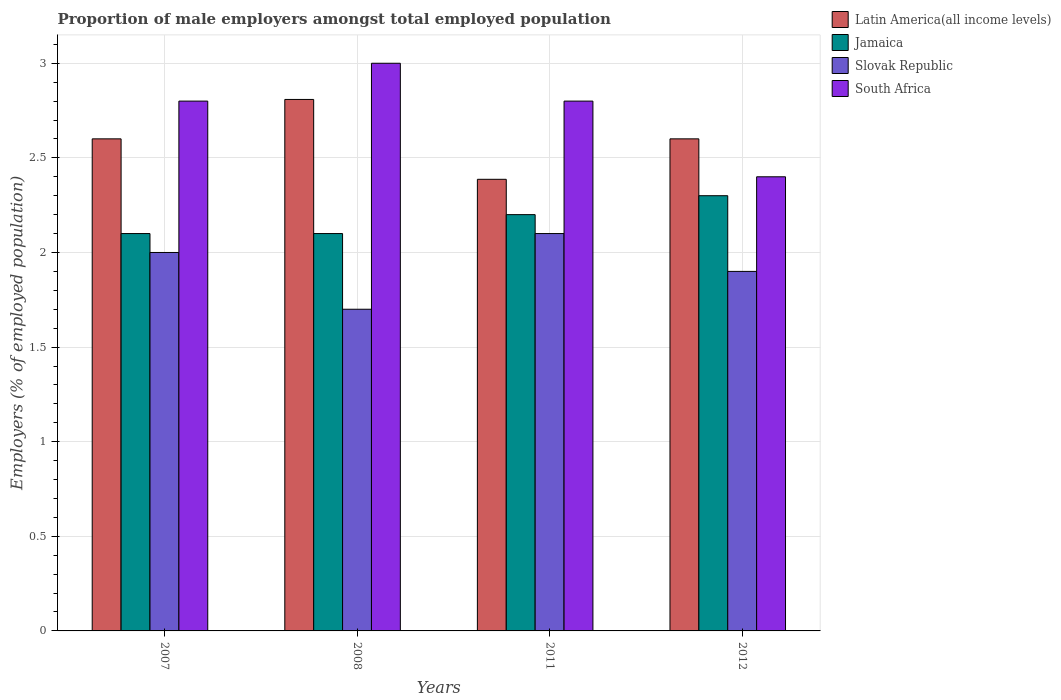How many different coloured bars are there?
Offer a very short reply. 4. How many groups of bars are there?
Your response must be concise. 4. Are the number of bars per tick equal to the number of legend labels?
Provide a succinct answer. Yes. Are the number of bars on each tick of the X-axis equal?
Provide a short and direct response. Yes. How many bars are there on the 1st tick from the left?
Your answer should be very brief. 4. What is the proportion of male employers in Slovak Republic in 2012?
Offer a very short reply. 1.9. Across all years, what is the maximum proportion of male employers in Slovak Republic?
Ensure brevity in your answer.  2.1. Across all years, what is the minimum proportion of male employers in Latin America(all income levels)?
Offer a very short reply. 2.39. In which year was the proportion of male employers in Jamaica maximum?
Provide a succinct answer. 2012. In which year was the proportion of male employers in Jamaica minimum?
Provide a succinct answer. 2007. What is the total proportion of male employers in South Africa in the graph?
Your response must be concise. 11. What is the difference between the proportion of male employers in South Africa in 2007 and that in 2012?
Provide a succinct answer. 0.4. What is the average proportion of male employers in Latin America(all income levels) per year?
Offer a very short reply. 2.6. In the year 2012, what is the difference between the proportion of male employers in Latin America(all income levels) and proportion of male employers in Slovak Republic?
Keep it short and to the point. 0.7. What is the ratio of the proportion of male employers in Slovak Republic in 2007 to that in 2008?
Ensure brevity in your answer.  1.18. Is the proportion of male employers in Jamaica in 2007 less than that in 2012?
Your answer should be compact. Yes. Is the difference between the proportion of male employers in Latin America(all income levels) in 2008 and 2011 greater than the difference between the proportion of male employers in Slovak Republic in 2008 and 2011?
Offer a very short reply. Yes. What is the difference between the highest and the second highest proportion of male employers in South Africa?
Keep it short and to the point. 0.2. What is the difference between the highest and the lowest proportion of male employers in Latin America(all income levels)?
Offer a terse response. 0.42. Is it the case that in every year, the sum of the proportion of male employers in Jamaica and proportion of male employers in Latin America(all income levels) is greater than the sum of proportion of male employers in Slovak Republic and proportion of male employers in South Africa?
Ensure brevity in your answer.  Yes. What does the 3rd bar from the left in 2012 represents?
Keep it short and to the point. Slovak Republic. What does the 2nd bar from the right in 2012 represents?
Provide a succinct answer. Slovak Republic. How many bars are there?
Offer a terse response. 16. How many years are there in the graph?
Your answer should be very brief. 4. What is the difference between two consecutive major ticks on the Y-axis?
Provide a short and direct response. 0.5. Does the graph contain any zero values?
Ensure brevity in your answer.  No. Does the graph contain grids?
Make the answer very short. Yes. Where does the legend appear in the graph?
Ensure brevity in your answer.  Top right. How are the legend labels stacked?
Provide a short and direct response. Vertical. What is the title of the graph?
Make the answer very short. Proportion of male employers amongst total employed population. What is the label or title of the Y-axis?
Offer a terse response. Employers (% of employed population). What is the Employers (% of employed population) of Latin America(all income levels) in 2007?
Give a very brief answer. 2.6. What is the Employers (% of employed population) in Jamaica in 2007?
Ensure brevity in your answer.  2.1. What is the Employers (% of employed population) of Slovak Republic in 2007?
Give a very brief answer. 2. What is the Employers (% of employed population) in South Africa in 2007?
Offer a very short reply. 2.8. What is the Employers (% of employed population) of Latin America(all income levels) in 2008?
Offer a very short reply. 2.81. What is the Employers (% of employed population) of Jamaica in 2008?
Ensure brevity in your answer.  2.1. What is the Employers (% of employed population) of Slovak Republic in 2008?
Provide a short and direct response. 1.7. What is the Employers (% of employed population) in Latin America(all income levels) in 2011?
Ensure brevity in your answer.  2.39. What is the Employers (% of employed population) in Jamaica in 2011?
Offer a terse response. 2.2. What is the Employers (% of employed population) in Slovak Republic in 2011?
Provide a succinct answer. 2.1. What is the Employers (% of employed population) of South Africa in 2011?
Your answer should be compact. 2.8. What is the Employers (% of employed population) of Latin America(all income levels) in 2012?
Offer a very short reply. 2.6. What is the Employers (% of employed population) of Jamaica in 2012?
Your answer should be compact. 2.3. What is the Employers (% of employed population) in Slovak Republic in 2012?
Provide a succinct answer. 1.9. What is the Employers (% of employed population) of South Africa in 2012?
Ensure brevity in your answer.  2.4. Across all years, what is the maximum Employers (% of employed population) of Latin America(all income levels)?
Offer a very short reply. 2.81. Across all years, what is the maximum Employers (% of employed population) in Jamaica?
Ensure brevity in your answer.  2.3. Across all years, what is the maximum Employers (% of employed population) in Slovak Republic?
Offer a terse response. 2.1. Across all years, what is the minimum Employers (% of employed population) of Latin America(all income levels)?
Keep it short and to the point. 2.39. Across all years, what is the minimum Employers (% of employed population) in Jamaica?
Make the answer very short. 2.1. Across all years, what is the minimum Employers (% of employed population) of Slovak Republic?
Give a very brief answer. 1.7. Across all years, what is the minimum Employers (% of employed population) of South Africa?
Your answer should be very brief. 2.4. What is the total Employers (% of employed population) in Latin America(all income levels) in the graph?
Provide a succinct answer. 10.4. What is the total Employers (% of employed population) in Slovak Republic in the graph?
Your response must be concise. 7.7. What is the difference between the Employers (% of employed population) in Latin America(all income levels) in 2007 and that in 2008?
Your answer should be compact. -0.21. What is the difference between the Employers (% of employed population) in Jamaica in 2007 and that in 2008?
Offer a very short reply. 0. What is the difference between the Employers (% of employed population) in South Africa in 2007 and that in 2008?
Your answer should be very brief. -0.2. What is the difference between the Employers (% of employed population) in Latin America(all income levels) in 2007 and that in 2011?
Make the answer very short. 0.21. What is the difference between the Employers (% of employed population) in Jamaica in 2007 and that in 2011?
Your answer should be very brief. -0.1. What is the difference between the Employers (% of employed population) in South Africa in 2007 and that in 2011?
Your answer should be very brief. 0. What is the difference between the Employers (% of employed population) of Jamaica in 2007 and that in 2012?
Your answer should be very brief. -0.2. What is the difference between the Employers (% of employed population) in Latin America(all income levels) in 2008 and that in 2011?
Your answer should be compact. 0.42. What is the difference between the Employers (% of employed population) in Slovak Republic in 2008 and that in 2011?
Make the answer very short. -0.4. What is the difference between the Employers (% of employed population) of Latin America(all income levels) in 2008 and that in 2012?
Your response must be concise. 0.21. What is the difference between the Employers (% of employed population) in Jamaica in 2008 and that in 2012?
Offer a terse response. -0.2. What is the difference between the Employers (% of employed population) of South Africa in 2008 and that in 2012?
Provide a succinct answer. 0.6. What is the difference between the Employers (% of employed population) of Latin America(all income levels) in 2011 and that in 2012?
Offer a very short reply. -0.21. What is the difference between the Employers (% of employed population) in Slovak Republic in 2011 and that in 2012?
Provide a succinct answer. 0.2. What is the difference between the Employers (% of employed population) of Latin America(all income levels) in 2007 and the Employers (% of employed population) of Jamaica in 2008?
Ensure brevity in your answer.  0.5. What is the difference between the Employers (% of employed population) of Latin America(all income levels) in 2007 and the Employers (% of employed population) of Slovak Republic in 2008?
Give a very brief answer. 0.9. What is the difference between the Employers (% of employed population) of Latin America(all income levels) in 2007 and the Employers (% of employed population) of South Africa in 2008?
Your response must be concise. -0.4. What is the difference between the Employers (% of employed population) of Latin America(all income levels) in 2007 and the Employers (% of employed population) of Jamaica in 2011?
Your answer should be compact. 0.4. What is the difference between the Employers (% of employed population) of Latin America(all income levels) in 2007 and the Employers (% of employed population) of Slovak Republic in 2011?
Make the answer very short. 0.5. What is the difference between the Employers (% of employed population) of Latin America(all income levels) in 2007 and the Employers (% of employed population) of South Africa in 2011?
Make the answer very short. -0.2. What is the difference between the Employers (% of employed population) of Jamaica in 2007 and the Employers (% of employed population) of South Africa in 2011?
Your answer should be very brief. -0.7. What is the difference between the Employers (% of employed population) in Latin America(all income levels) in 2007 and the Employers (% of employed population) in Jamaica in 2012?
Give a very brief answer. 0.3. What is the difference between the Employers (% of employed population) in Latin America(all income levels) in 2007 and the Employers (% of employed population) in Slovak Republic in 2012?
Keep it short and to the point. 0.7. What is the difference between the Employers (% of employed population) in Latin America(all income levels) in 2007 and the Employers (% of employed population) in South Africa in 2012?
Keep it short and to the point. 0.2. What is the difference between the Employers (% of employed population) of Latin America(all income levels) in 2008 and the Employers (% of employed population) of Jamaica in 2011?
Your answer should be compact. 0.61. What is the difference between the Employers (% of employed population) of Latin America(all income levels) in 2008 and the Employers (% of employed population) of Slovak Republic in 2011?
Offer a very short reply. 0.71. What is the difference between the Employers (% of employed population) in Latin America(all income levels) in 2008 and the Employers (% of employed population) in South Africa in 2011?
Provide a succinct answer. 0.01. What is the difference between the Employers (% of employed population) in Jamaica in 2008 and the Employers (% of employed population) in South Africa in 2011?
Provide a short and direct response. -0.7. What is the difference between the Employers (% of employed population) in Slovak Republic in 2008 and the Employers (% of employed population) in South Africa in 2011?
Provide a succinct answer. -1.1. What is the difference between the Employers (% of employed population) in Latin America(all income levels) in 2008 and the Employers (% of employed population) in Jamaica in 2012?
Offer a terse response. 0.51. What is the difference between the Employers (% of employed population) of Latin America(all income levels) in 2008 and the Employers (% of employed population) of Slovak Republic in 2012?
Make the answer very short. 0.91. What is the difference between the Employers (% of employed population) of Latin America(all income levels) in 2008 and the Employers (% of employed population) of South Africa in 2012?
Your answer should be compact. 0.41. What is the difference between the Employers (% of employed population) in Slovak Republic in 2008 and the Employers (% of employed population) in South Africa in 2012?
Provide a short and direct response. -0.7. What is the difference between the Employers (% of employed population) of Latin America(all income levels) in 2011 and the Employers (% of employed population) of Jamaica in 2012?
Offer a very short reply. 0.09. What is the difference between the Employers (% of employed population) of Latin America(all income levels) in 2011 and the Employers (% of employed population) of Slovak Republic in 2012?
Ensure brevity in your answer.  0.49. What is the difference between the Employers (% of employed population) in Latin America(all income levels) in 2011 and the Employers (% of employed population) in South Africa in 2012?
Keep it short and to the point. -0.01. What is the difference between the Employers (% of employed population) of Jamaica in 2011 and the Employers (% of employed population) of Slovak Republic in 2012?
Provide a short and direct response. 0.3. What is the difference between the Employers (% of employed population) in Jamaica in 2011 and the Employers (% of employed population) in South Africa in 2012?
Offer a very short reply. -0.2. What is the difference between the Employers (% of employed population) of Slovak Republic in 2011 and the Employers (% of employed population) of South Africa in 2012?
Keep it short and to the point. -0.3. What is the average Employers (% of employed population) of Latin America(all income levels) per year?
Offer a terse response. 2.6. What is the average Employers (% of employed population) of Jamaica per year?
Give a very brief answer. 2.17. What is the average Employers (% of employed population) of Slovak Republic per year?
Provide a short and direct response. 1.93. What is the average Employers (% of employed population) in South Africa per year?
Make the answer very short. 2.75. In the year 2007, what is the difference between the Employers (% of employed population) of Latin America(all income levels) and Employers (% of employed population) of Jamaica?
Your answer should be very brief. 0.5. In the year 2007, what is the difference between the Employers (% of employed population) of Latin America(all income levels) and Employers (% of employed population) of Slovak Republic?
Provide a short and direct response. 0.6. In the year 2007, what is the difference between the Employers (% of employed population) of Latin America(all income levels) and Employers (% of employed population) of South Africa?
Your answer should be very brief. -0.2. In the year 2007, what is the difference between the Employers (% of employed population) of Jamaica and Employers (% of employed population) of Slovak Republic?
Provide a short and direct response. 0.1. In the year 2008, what is the difference between the Employers (% of employed population) in Latin America(all income levels) and Employers (% of employed population) in Jamaica?
Your response must be concise. 0.71. In the year 2008, what is the difference between the Employers (% of employed population) of Latin America(all income levels) and Employers (% of employed population) of Slovak Republic?
Keep it short and to the point. 1.11. In the year 2008, what is the difference between the Employers (% of employed population) of Latin America(all income levels) and Employers (% of employed population) of South Africa?
Offer a very short reply. -0.19. In the year 2008, what is the difference between the Employers (% of employed population) of Jamaica and Employers (% of employed population) of Slovak Republic?
Your answer should be very brief. 0.4. In the year 2008, what is the difference between the Employers (% of employed population) of Jamaica and Employers (% of employed population) of South Africa?
Ensure brevity in your answer.  -0.9. In the year 2011, what is the difference between the Employers (% of employed population) of Latin America(all income levels) and Employers (% of employed population) of Jamaica?
Make the answer very short. 0.19. In the year 2011, what is the difference between the Employers (% of employed population) of Latin America(all income levels) and Employers (% of employed population) of Slovak Republic?
Keep it short and to the point. 0.29. In the year 2011, what is the difference between the Employers (% of employed population) in Latin America(all income levels) and Employers (% of employed population) in South Africa?
Give a very brief answer. -0.41. In the year 2011, what is the difference between the Employers (% of employed population) of Jamaica and Employers (% of employed population) of Slovak Republic?
Ensure brevity in your answer.  0.1. In the year 2011, what is the difference between the Employers (% of employed population) of Jamaica and Employers (% of employed population) of South Africa?
Your response must be concise. -0.6. In the year 2011, what is the difference between the Employers (% of employed population) in Slovak Republic and Employers (% of employed population) in South Africa?
Provide a succinct answer. -0.7. In the year 2012, what is the difference between the Employers (% of employed population) of Latin America(all income levels) and Employers (% of employed population) of Jamaica?
Provide a short and direct response. 0.3. In the year 2012, what is the difference between the Employers (% of employed population) in Latin America(all income levels) and Employers (% of employed population) in Slovak Republic?
Give a very brief answer. 0.7. In the year 2012, what is the difference between the Employers (% of employed population) in Latin America(all income levels) and Employers (% of employed population) in South Africa?
Your answer should be very brief. 0.2. What is the ratio of the Employers (% of employed population) in Latin America(all income levels) in 2007 to that in 2008?
Provide a succinct answer. 0.93. What is the ratio of the Employers (% of employed population) of Jamaica in 2007 to that in 2008?
Your answer should be very brief. 1. What is the ratio of the Employers (% of employed population) in Slovak Republic in 2007 to that in 2008?
Your answer should be compact. 1.18. What is the ratio of the Employers (% of employed population) in South Africa in 2007 to that in 2008?
Keep it short and to the point. 0.93. What is the ratio of the Employers (% of employed population) in Latin America(all income levels) in 2007 to that in 2011?
Make the answer very short. 1.09. What is the ratio of the Employers (% of employed population) in Jamaica in 2007 to that in 2011?
Make the answer very short. 0.95. What is the ratio of the Employers (% of employed population) in Slovak Republic in 2007 to that in 2011?
Ensure brevity in your answer.  0.95. What is the ratio of the Employers (% of employed population) in Latin America(all income levels) in 2007 to that in 2012?
Your answer should be very brief. 1. What is the ratio of the Employers (% of employed population) of Slovak Republic in 2007 to that in 2012?
Offer a terse response. 1.05. What is the ratio of the Employers (% of employed population) in South Africa in 2007 to that in 2012?
Your answer should be very brief. 1.17. What is the ratio of the Employers (% of employed population) of Latin America(all income levels) in 2008 to that in 2011?
Provide a succinct answer. 1.18. What is the ratio of the Employers (% of employed population) in Jamaica in 2008 to that in 2011?
Offer a very short reply. 0.95. What is the ratio of the Employers (% of employed population) in Slovak Republic in 2008 to that in 2011?
Ensure brevity in your answer.  0.81. What is the ratio of the Employers (% of employed population) in South Africa in 2008 to that in 2011?
Ensure brevity in your answer.  1.07. What is the ratio of the Employers (% of employed population) in Latin America(all income levels) in 2008 to that in 2012?
Offer a terse response. 1.08. What is the ratio of the Employers (% of employed population) of Slovak Republic in 2008 to that in 2012?
Provide a short and direct response. 0.89. What is the ratio of the Employers (% of employed population) in Latin America(all income levels) in 2011 to that in 2012?
Your response must be concise. 0.92. What is the ratio of the Employers (% of employed population) in Jamaica in 2011 to that in 2012?
Offer a very short reply. 0.96. What is the ratio of the Employers (% of employed population) in Slovak Republic in 2011 to that in 2012?
Your answer should be very brief. 1.11. What is the ratio of the Employers (% of employed population) in South Africa in 2011 to that in 2012?
Provide a succinct answer. 1.17. What is the difference between the highest and the second highest Employers (% of employed population) of Latin America(all income levels)?
Provide a succinct answer. 0.21. What is the difference between the highest and the second highest Employers (% of employed population) of Jamaica?
Your response must be concise. 0.1. What is the difference between the highest and the second highest Employers (% of employed population) of Slovak Republic?
Offer a terse response. 0.1. What is the difference between the highest and the lowest Employers (% of employed population) in Latin America(all income levels)?
Provide a succinct answer. 0.42. What is the difference between the highest and the lowest Employers (% of employed population) in Jamaica?
Provide a short and direct response. 0.2. What is the difference between the highest and the lowest Employers (% of employed population) of South Africa?
Offer a terse response. 0.6. 